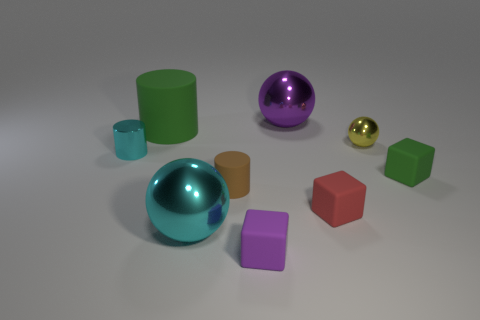Is the number of big cyan objects greater than the number of small matte things?
Your response must be concise. No. Are there any green cubes of the same size as the purple cube?
Offer a terse response. Yes. How many objects are shiny things on the left side of the large green matte object or green objects to the left of the tiny matte cylinder?
Make the answer very short. 2. There is a big sphere that is in front of the tiny rubber thing that is behind the brown matte object; what color is it?
Keep it short and to the point. Cyan. What color is the other large cylinder that is made of the same material as the brown cylinder?
Your answer should be compact. Green. How many other big cylinders are the same color as the big cylinder?
Your answer should be very brief. 0. What number of things are either purple shiny cylinders or purple metallic things?
Make the answer very short. 1. There is a green thing that is the same size as the purple rubber cube; what is its shape?
Your answer should be compact. Cube. What number of small things are both on the left side of the purple sphere and behind the purple matte cube?
Ensure brevity in your answer.  2. What is the material of the green object that is left of the large purple thing?
Ensure brevity in your answer.  Rubber. 